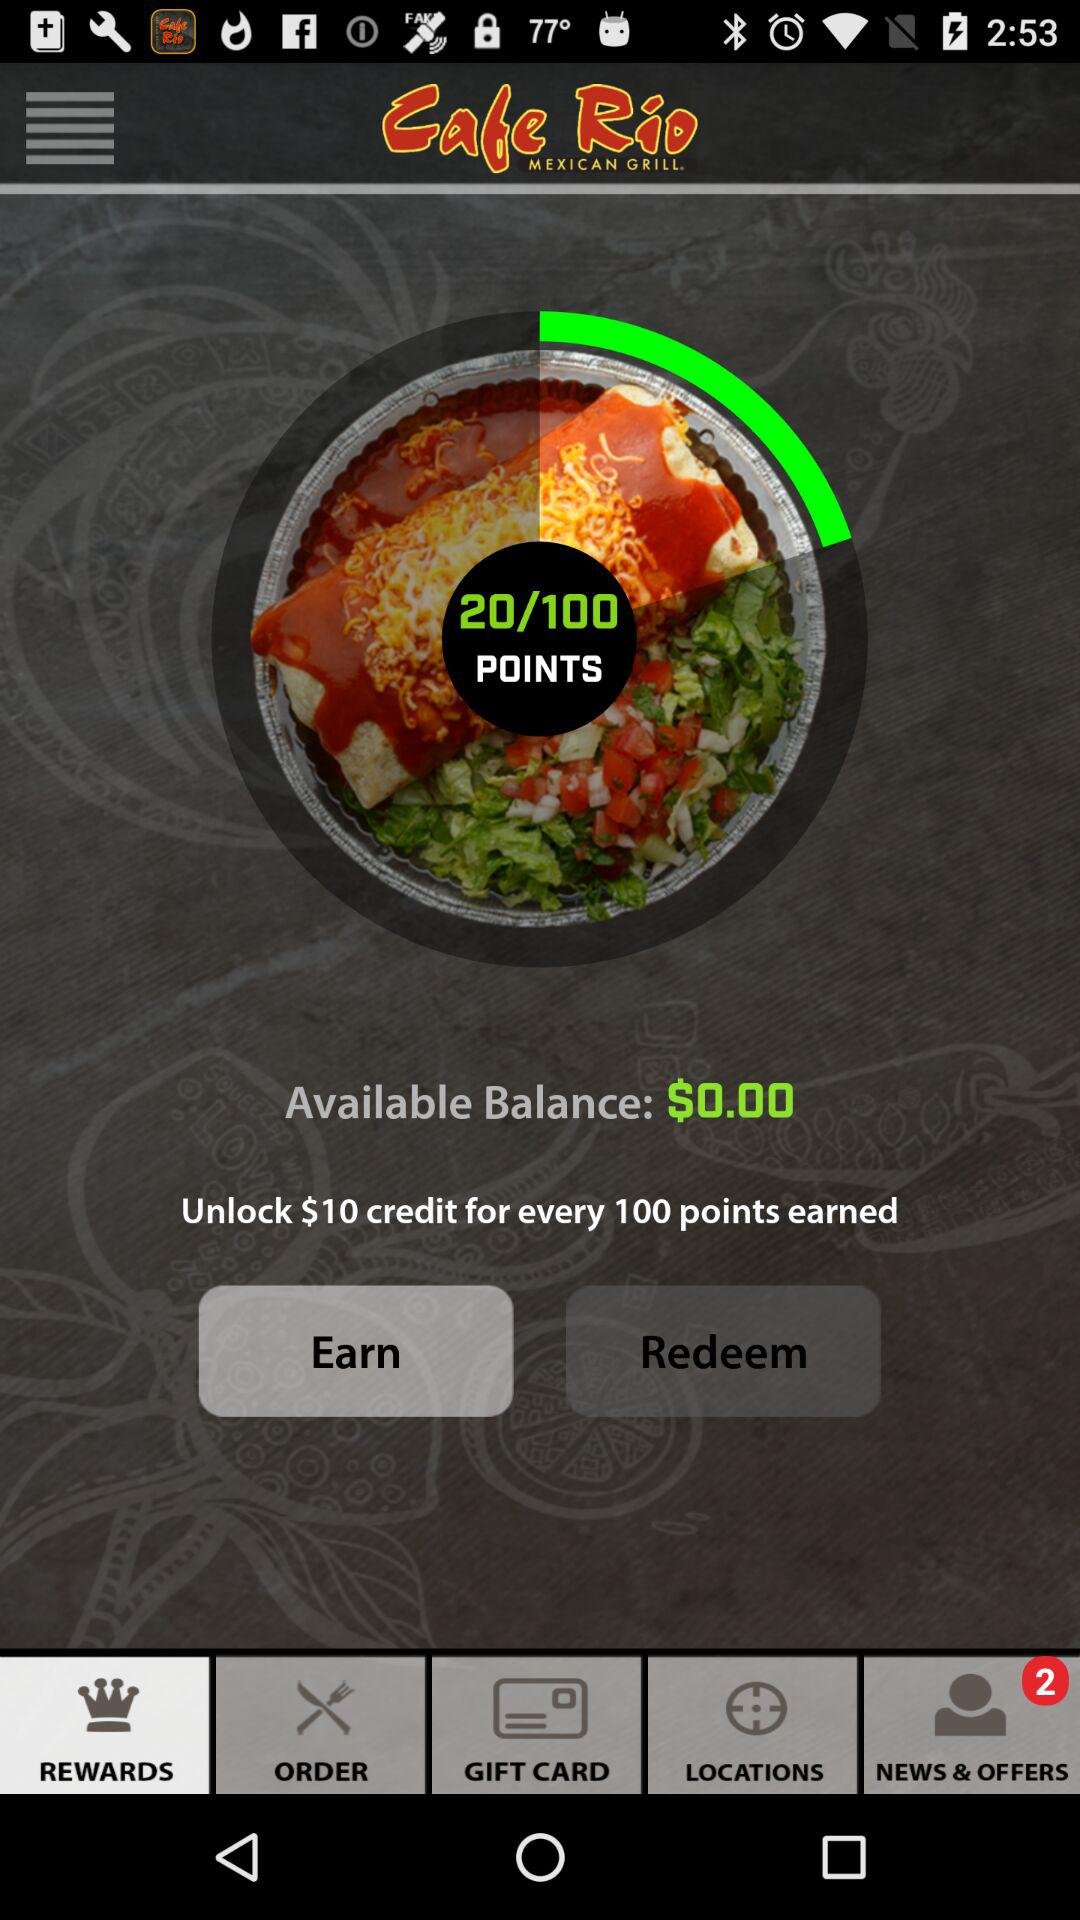What's currently the available balance on this rewards account? As indicated on the screen, the available balance on this rewards account is currently $0.00. 